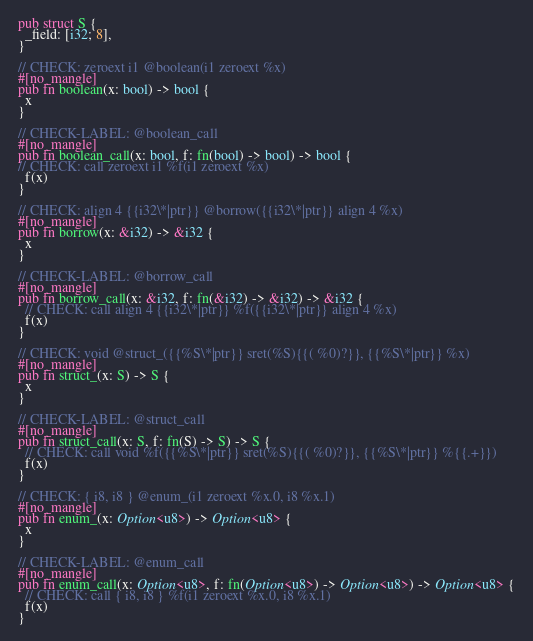Convert code to text. <code><loc_0><loc_0><loc_500><loc_500><_Rust_>pub struct S {
  _field: [i32; 8],
}

// CHECK: zeroext i1 @boolean(i1 zeroext %x)
#[no_mangle]
pub fn boolean(x: bool) -> bool {
  x
}

// CHECK-LABEL: @boolean_call
#[no_mangle]
pub fn boolean_call(x: bool, f: fn(bool) -> bool) -> bool {
// CHECK: call zeroext i1 %f(i1 zeroext %x)
  f(x)
}

// CHECK: align 4 {{i32\*|ptr}} @borrow({{i32\*|ptr}} align 4 %x)
#[no_mangle]
pub fn borrow(x: &i32) -> &i32 {
  x
}

// CHECK-LABEL: @borrow_call
#[no_mangle]
pub fn borrow_call(x: &i32, f: fn(&i32) -> &i32) -> &i32 {
  // CHECK: call align 4 {{i32\*|ptr}} %f({{i32\*|ptr}} align 4 %x)
  f(x)
}

// CHECK: void @struct_({{%S\*|ptr}} sret(%S){{( %0)?}}, {{%S\*|ptr}} %x)
#[no_mangle]
pub fn struct_(x: S) -> S {
  x
}

// CHECK-LABEL: @struct_call
#[no_mangle]
pub fn struct_call(x: S, f: fn(S) -> S) -> S {
  // CHECK: call void %f({{%S\*|ptr}} sret(%S){{( %0)?}}, {{%S\*|ptr}} %{{.+}})
  f(x)
}

// CHECK: { i8, i8 } @enum_(i1 zeroext %x.0, i8 %x.1)
#[no_mangle]
pub fn enum_(x: Option<u8>) -> Option<u8> {
  x
}

// CHECK-LABEL: @enum_call
#[no_mangle]
pub fn enum_call(x: Option<u8>, f: fn(Option<u8>) -> Option<u8>) -> Option<u8> {
  // CHECK: call { i8, i8 } %f(i1 zeroext %x.0, i8 %x.1)
  f(x)
}
</code> 